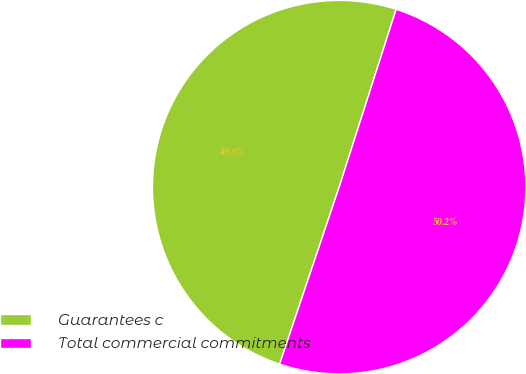Convert chart to OTSL. <chart><loc_0><loc_0><loc_500><loc_500><pie_chart><fcel>Guarantees c<fcel>Total commercial commitments<nl><fcel>49.77%<fcel>50.23%<nl></chart> 